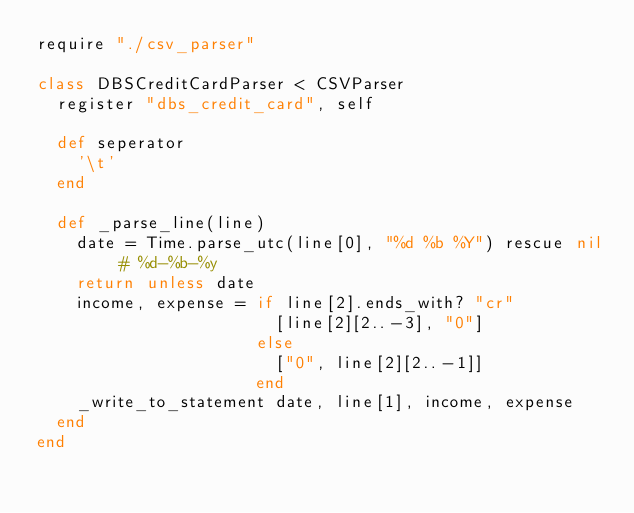<code> <loc_0><loc_0><loc_500><loc_500><_Crystal_>require "./csv_parser"

class DBSCreditCardParser < CSVParser
  register "dbs_credit_card", self

  def seperator
    '\t'
  end

  def _parse_line(line)
    date = Time.parse_utc(line[0], "%d %b %Y") rescue nil # %d-%b-%y
    return unless date
    income, expense = if line[2].ends_with? "cr"
                        [line[2][2..-3], "0"]
                      else
                        ["0", line[2][2..-1]]
                      end
    _write_to_statement date, line[1], income, expense
  end
end
</code> 